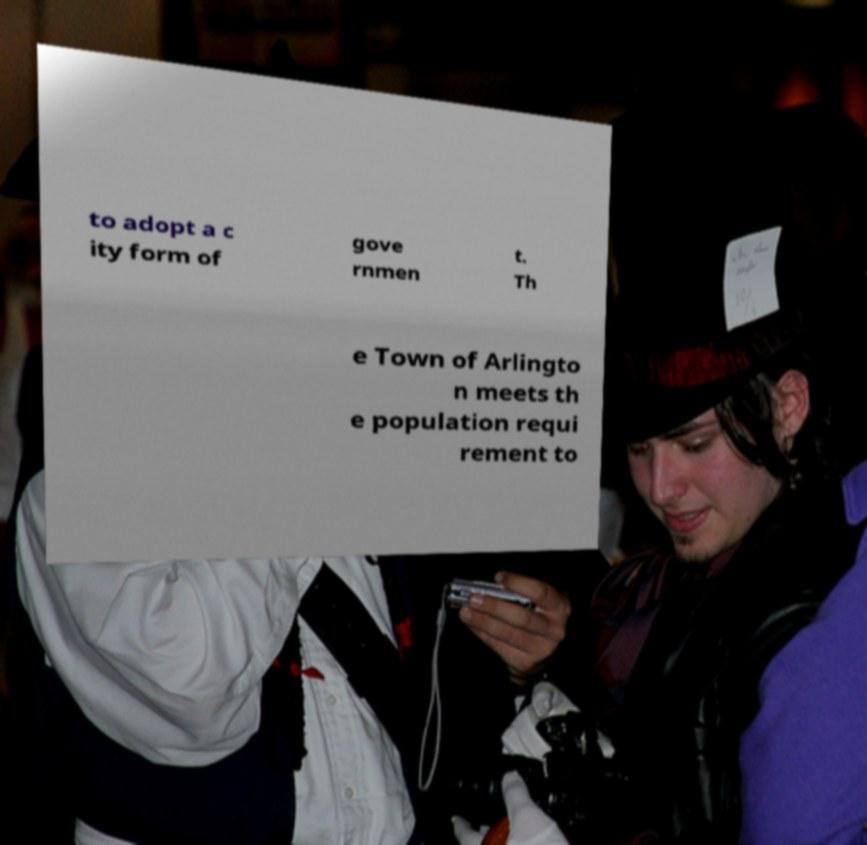Please read and relay the text visible in this image. What does it say? to adopt a c ity form of gove rnmen t. Th e Town of Arlingto n meets th e population requi rement to 